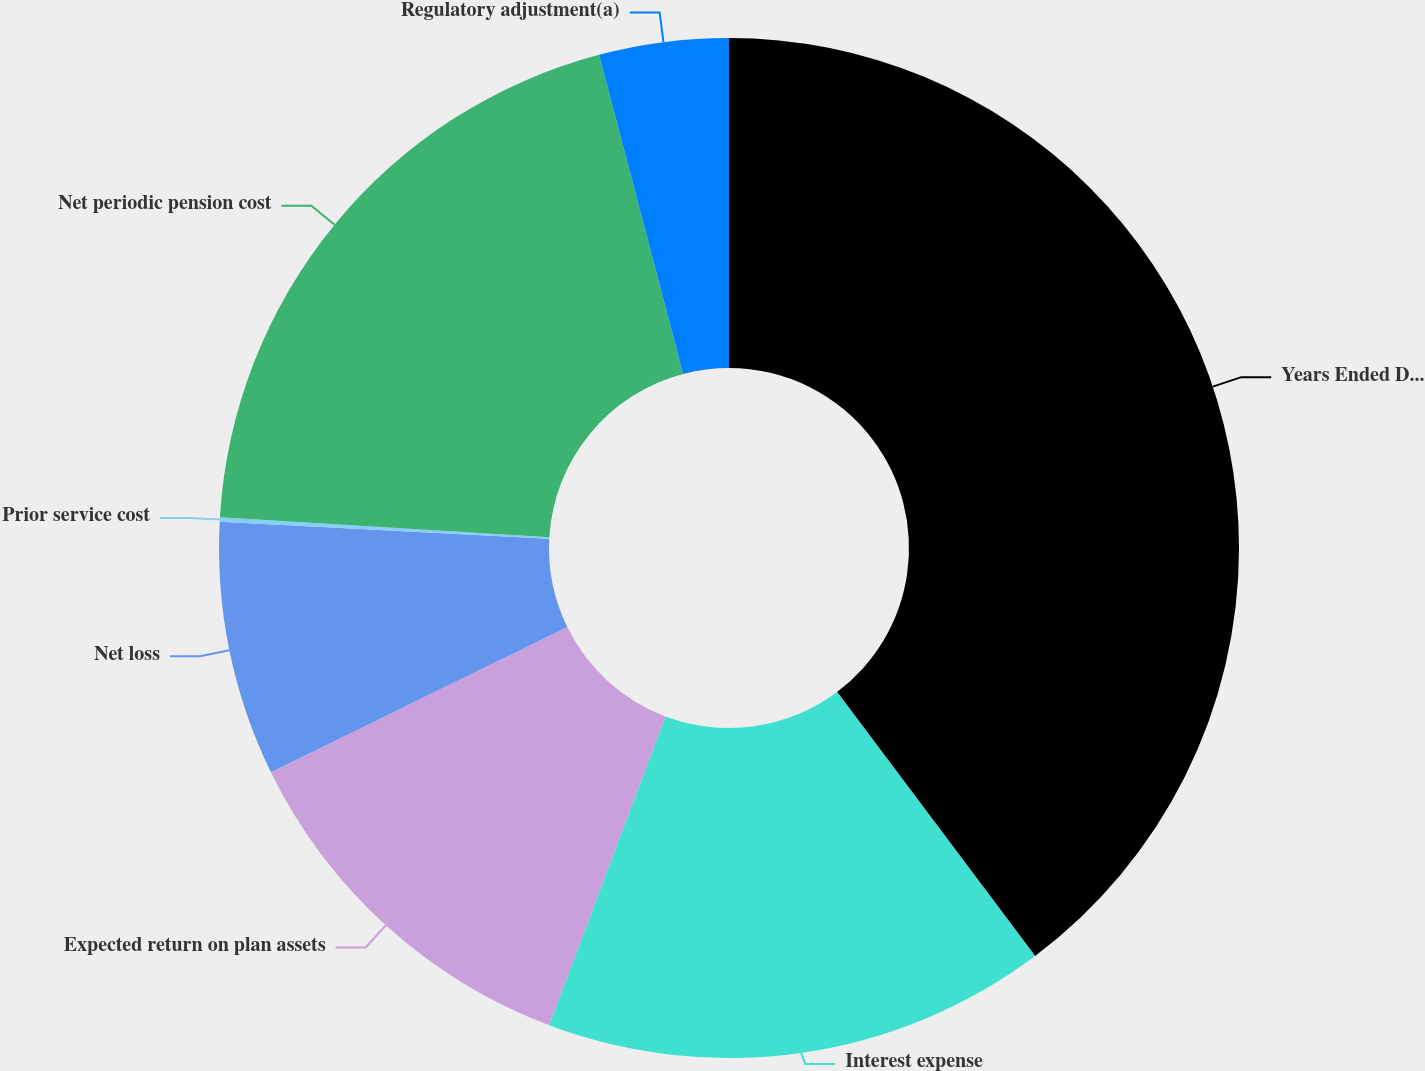<chart> <loc_0><loc_0><loc_500><loc_500><pie_chart><fcel>Years Ended December 31<fcel>Interest expense<fcel>Expected return on plan assets<fcel>Net loss<fcel>Prior service cost<fcel>Net periodic pension cost<fcel>Regulatory adjustment(a)<nl><fcel>39.75%<fcel>15.98%<fcel>12.02%<fcel>8.06%<fcel>0.14%<fcel>19.94%<fcel>4.1%<nl></chart> 